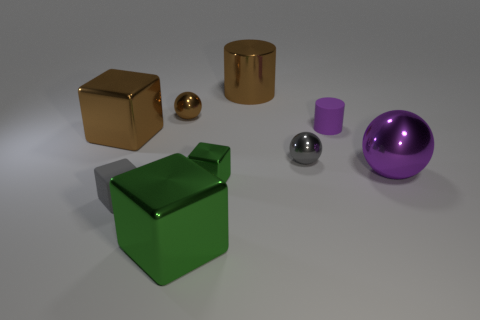What number of spheres are green metal things or gray shiny objects?
Provide a short and direct response. 1. How many gray balls are to the right of the brown metal object in front of the matte cylinder?
Your answer should be very brief. 1. Does the large purple metallic thing have the same shape as the big green thing?
Your answer should be very brief. No. What is the size of the brown metallic object that is the same shape as the tiny green shiny object?
Provide a short and direct response. Large. The purple object that is to the left of the large object that is to the right of the matte cylinder is what shape?
Offer a terse response. Cylinder. The brown metallic cylinder has what size?
Your response must be concise. Large. The big purple shiny object has what shape?
Keep it short and to the point. Sphere. Is the shape of the tiny green thing the same as the large brown metallic object that is behind the small purple matte cylinder?
Make the answer very short. No. There is a tiny gray thing that is behind the small gray matte cube; is it the same shape as the large purple metallic thing?
Make the answer very short. Yes. How many big metallic things are both in front of the gray metal sphere and behind the large brown block?
Give a very brief answer. 0. 